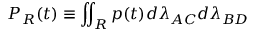Convert formula to latex. <formula><loc_0><loc_0><loc_500><loc_500>P _ { R } ( t ) \equiv \iint _ { R } p ( t ) d \lambda _ { A C } d \lambda _ { B D }</formula> 